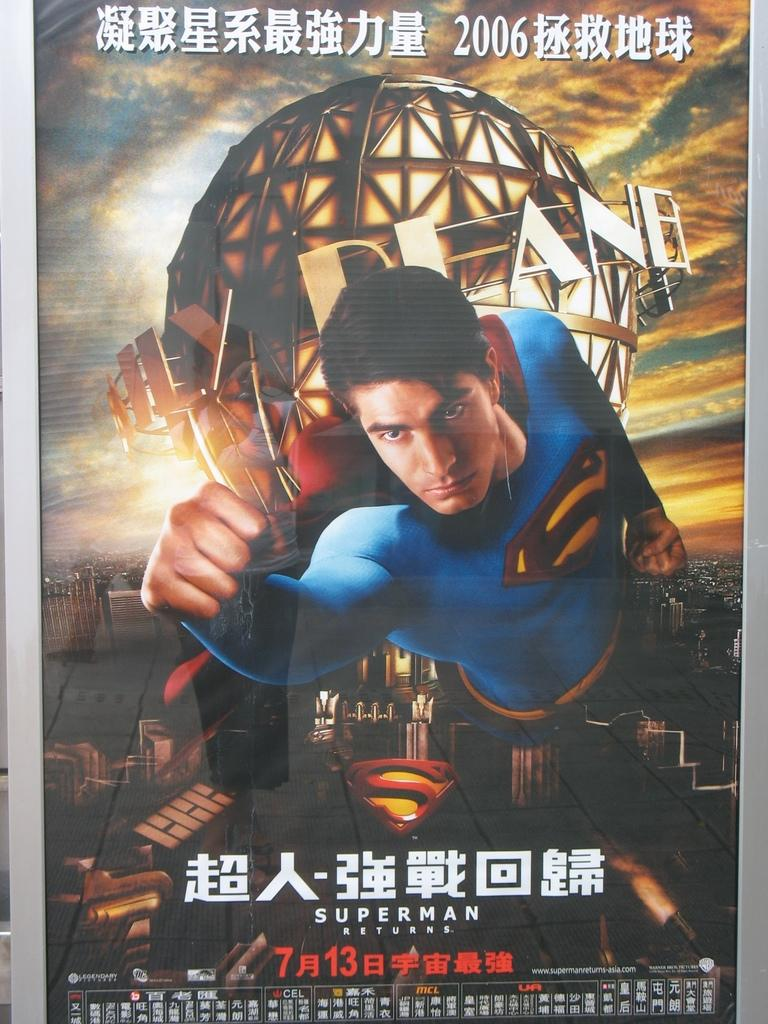What is the main object in the image? There is a poster in the image. What is shown on the poster? There is a person depicted on the poster. What can be seen in the background of the image? There are buildings in the background of the image. What else is featured on the poster besides the person? There is text or writing on the poster. What type of mass attraction can be seen in the image? There is no mass attraction present in the image; it features a poster with a person and text. Is there any rain visible in the image? There is no rain present in the image. 